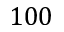<formula> <loc_0><loc_0><loc_500><loc_500>1 0 0</formula> 